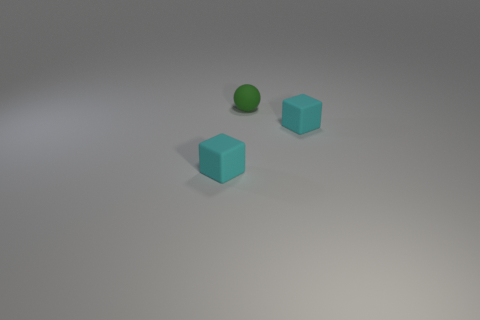What colors can be observed in this scene? In this scene, you can observe objects in cyan and a ball in green. The background consists of a neutral gray surface. 